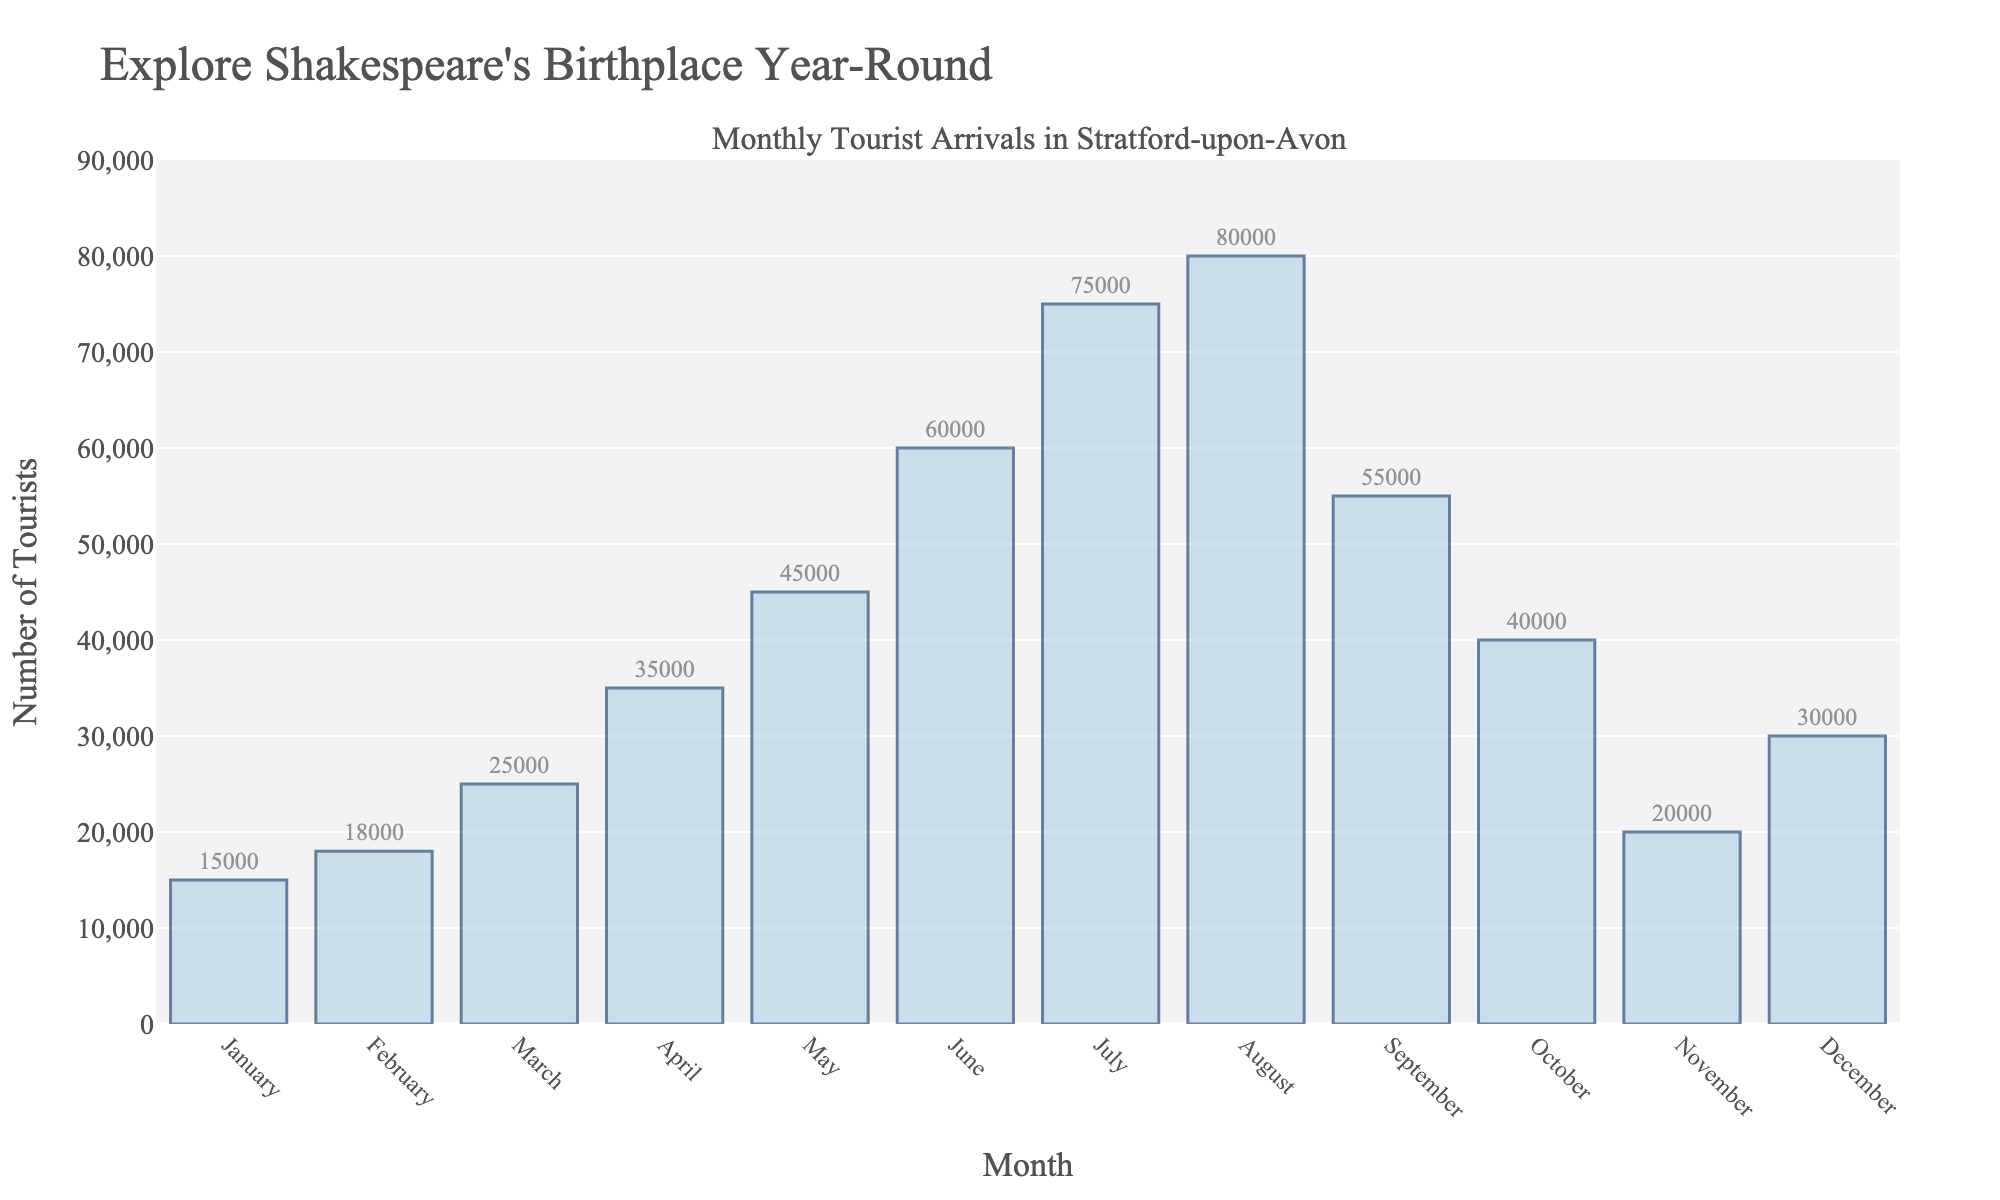How many tourists arrived in Stratford-upon-Avon in June and July combined? To find the total for June and July, add the tourist arrivals for both months. June had 60,000 arrivals and July had 75,000 arrivals. Adding these gives 60,000 + 75,000 = 135,000
Answer: 135,000 Which month had the highest number of tourist arrivals? Look at the bar chart and identify the tallest bar. August has the highest bar indicating the highest number of tourist arrivals at 80,000
Answer: August How many more tourists visited in August than in February? Subtract the number of tourists in February from the number in August. August had 80,000 visitors, and February had 18,000. So, 80,000 - 18,000 = 62,000
Answer: 62,000 What is the average number of tourists per month? Sum the tourist numbers for all months and divide by 12 (the number of months). The sum is 15,000 + 18,000 + 25,000 + 35,000 + 45,000 + 60,000 + 75,000 + 80,000 + 55,000 + 40,000 + 20,000 + 30,000 = 498,000. Dividing by 12 gives 498,000 / 12 = 41,500
Answer: 41,500 In which months did the number of tourists exceed 50,000? Look for bars taller than the 50,000 mark. The months with tourist arrivals greater than 50,000 are June, July, August, and September
Answer: June, July, August, September What is the difference in the number of tourists between the peak month and the month with the fewest tourists? Identify the peak and trough months from the bar chart. August has the highest number (80,000) and January the lowest (15,000). Subtract the lowest from the highest: 80,000 - 15,000 = 65,000
Answer: 65,000 Which months have a number of tourist arrivals closest to the yearly average? The yearly average is 41,500. Compare monthly arrivals to this average. October (40,000) and May (45,000) are closest to the average of 41,500 because the difference is smallest
Answer: October, May Is there a noticeable trend in tourist arrivals from January to August? Observe the bars from January to August. The height of the bars increases steadily, showing a rising trend in tourist arrivals up to August
Answer: Yes, increasing trend Which month has more tourists: March or October? Compare the heights of March and October bars. March has 25,000 tourists whereas October has 40,000
Answer: October By how much did tourist arrivals decrease from August to September? Subtract the number of tourists in September from the number in August. August had 80,000 visitors, and September had 55,000. So, 80,000 - 55,000 = 25,000
Answer: 25,000 